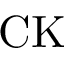<formula> <loc_0><loc_0><loc_500><loc_500>C K</formula> 